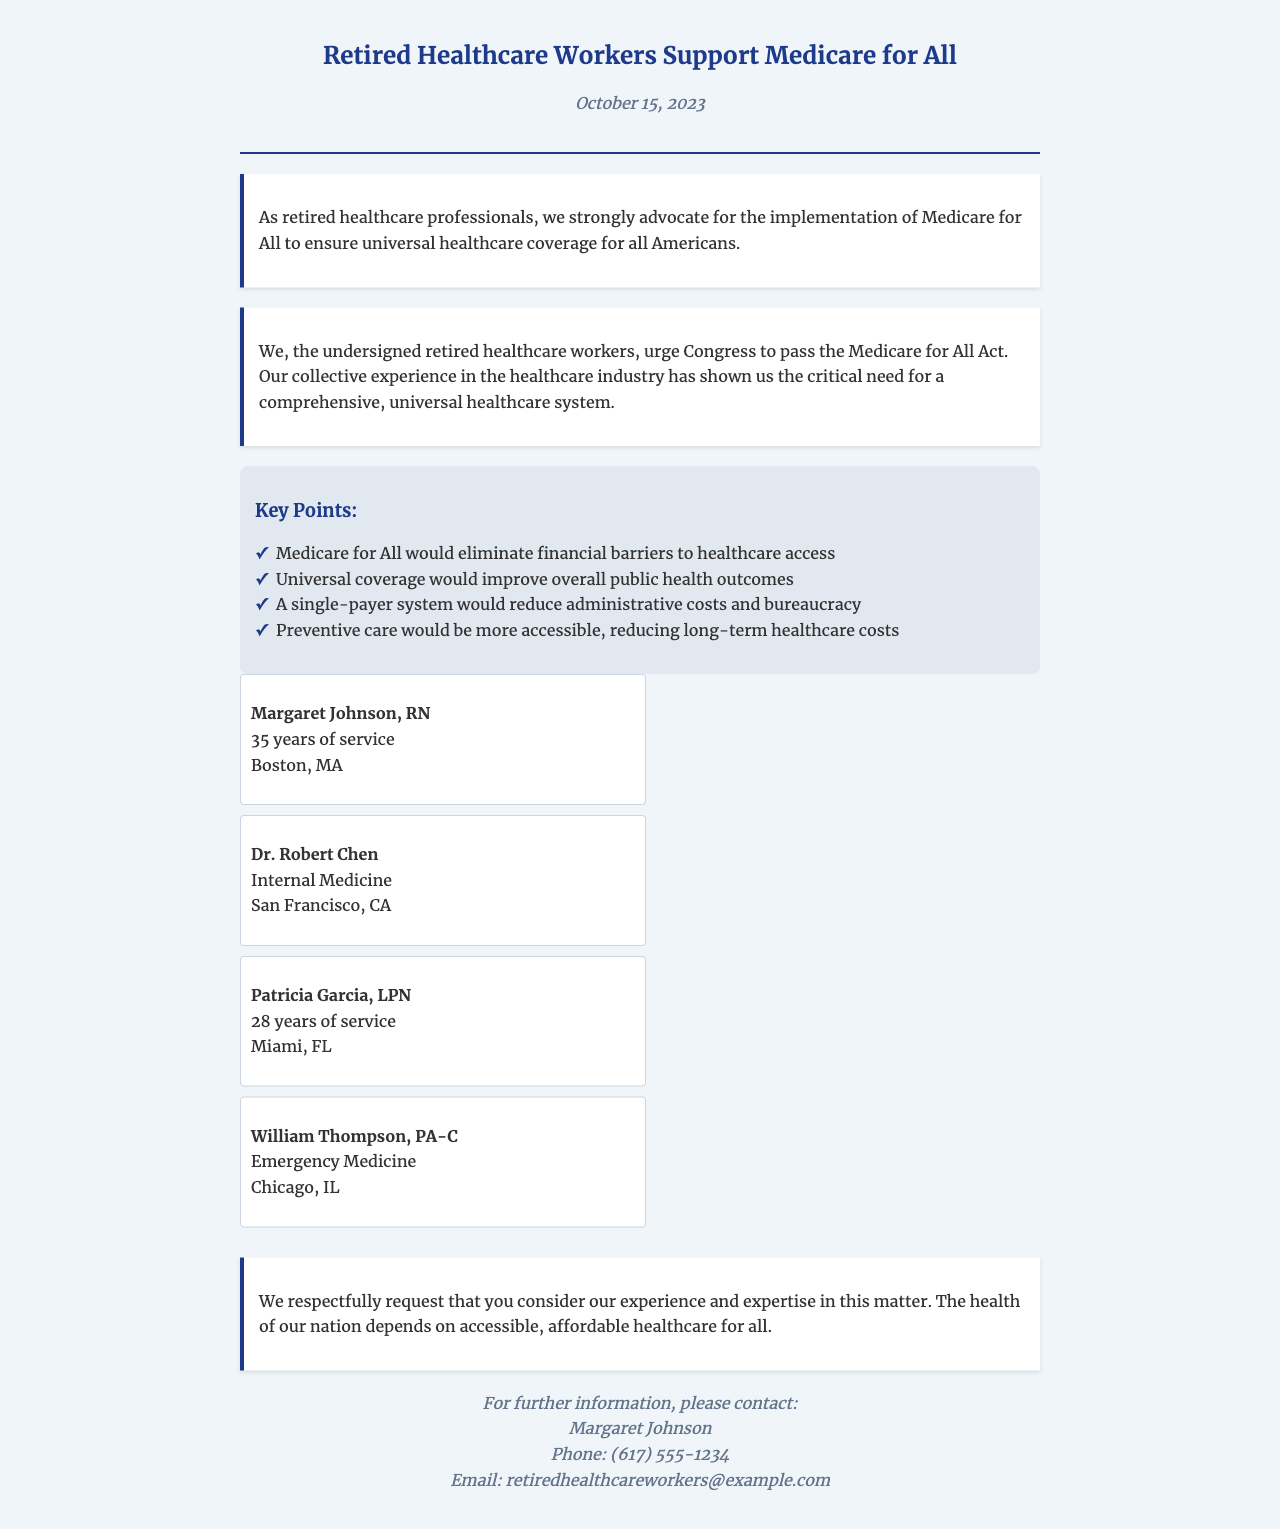What is the date of the fax? The date is explicitly mentioned in the document under the fax header, which is October 15, 2023.
Answer: October 15, 2023 Who is the first signatory on the petition? The first signature listed in the document is that of Margaret Johnson, RN.
Answer: Margaret Johnson, RN What is one key point mentioned in support of Medicare for All? The document lists several key points in a bullet format, including the elimination of financial barriers to healthcare access.
Answer: Eliminate financial barriers to healthcare access How many years of service does Patricia Garcia have? The document states that Patricia Garcia has 28 years of service listed under her signature.
Answer: 28 years What is the main request of the petition? The document conveys a request for Congress to pass the Medicare for All Act, which is articulated in the petition text.
Answer: Pass the Medicare for All Act Which city does Dr. Robert Chen practice in? Dr. Robert Chen is listed as practicing in San Francisco, CA, under his signature.
Answer: San Francisco, CA What kind of healthcare system is being advocated for in the document? The document advocates for a comprehensive, universal healthcare system referred to as Medicare for All.
Answer: Medicare for All How many signatures are displayed in the document? The document visually presents four signatures from retired healthcare workers supporting the petition.
Answer: Four signatures 